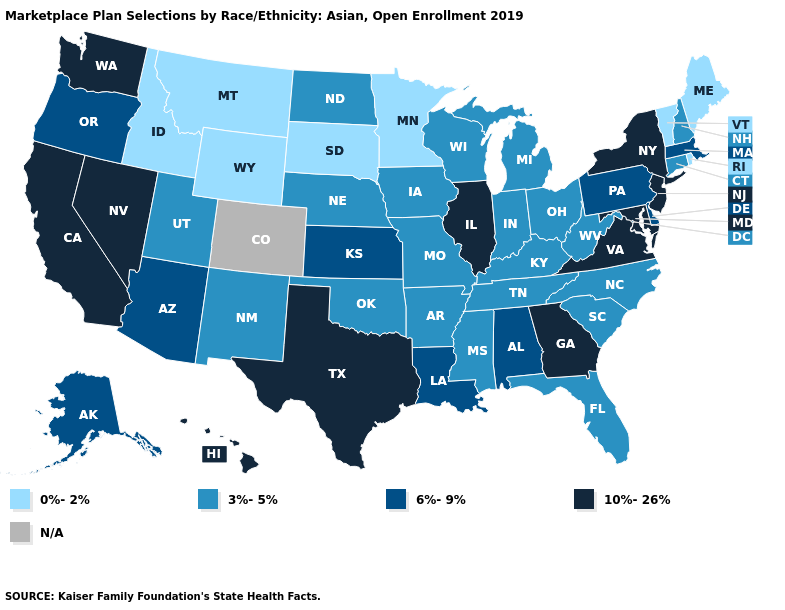What is the value of Rhode Island?
Quick response, please. 0%-2%. Name the states that have a value in the range 6%-9%?
Be succinct. Alabama, Alaska, Arizona, Delaware, Kansas, Louisiana, Massachusetts, Oregon, Pennsylvania. Name the states that have a value in the range 10%-26%?
Keep it brief. California, Georgia, Hawaii, Illinois, Maryland, Nevada, New Jersey, New York, Texas, Virginia, Washington. Name the states that have a value in the range 3%-5%?
Write a very short answer. Arkansas, Connecticut, Florida, Indiana, Iowa, Kentucky, Michigan, Mississippi, Missouri, Nebraska, New Hampshire, New Mexico, North Carolina, North Dakota, Ohio, Oklahoma, South Carolina, Tennessee, Utah, West Virginia, Wisconsin. What is the lowest value in the South?
Short answer required. 3%-5%. Which states have the highest value in the USA?
Keep it brief. California, Georgia, Hawaii, Illinois, Maryland, Nevada, New Jersey, New York, Texas, Virginia, Washington. Name the states that have a value in the range 10%-26%?
Be succinct. California, Georgia, Hawaii, Illinois, Maryland, Nevada, New Jersey, New York, Texas, Virginia, Washington. What is the lowest value in the USA?
Keep it brief. 0%-2%. Name the states that have a value in the range 10%-26%?
Answer briefly. California, Georgia, Hawaii, Illinois, Maryland, Nevada, New Jersey, New York, Texas, Virginia, Washington. What is the lowest value in the USA?
Keep it brief. 0%-2%. Does the first symbol in the legend represent the smallest category?
Be succinct. Yes. Name the states that have a value in the range 10%-26%?
Keep it brief. California, Georgia, Hawaii, Illinois, Maryland, Nevada, New Jersey, New York, Texas, Virginia, Washington. What is the highest value in the South ?
Keep it brief. 10%-26%. What is the highest value in states that border New Jersey?
Quick response, please. 10%-26%. Name the states that have a value in the range 6%-9%?
Answer briefly. Alabama, Alaska, Arizona, Delaware, Kansas, Louisiana, Massachusetts, Oregon, Pennsylvania. 